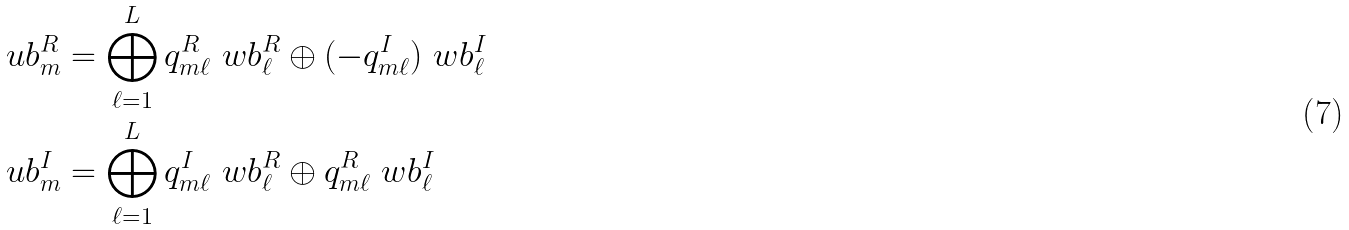Convert formula to latex. <formula><loc_0><loc_0><loc_500><loc_500>\ u b _ { m } ^ { R } & = \bigoplus _ { \ell = 1 } ^ { L } { q _ { m \ell } ^ { R } \ w b _ { \ell } ^ { R } \oplus ( - q _ { m \ell } ^ { I } ) \ w b _ { \ell } ^ { I } } \\ \ u b _ { m } ^ { I } & = \bigoplus _ { \ell = 1 } ^ { L } { q _ { m \ell } ^ { I } \ w b _ { \ell } ^ { R } \oplus q _ { m \ell } ^ { R } \ w b _ { \ell } ^ { I } }</formula> 